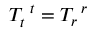Convert formula to latex. <formula><loc_0><loc_0><loc_500><loc_500>T _ { t } ^ { t } = T _ { r } ^ { r }</formula> 